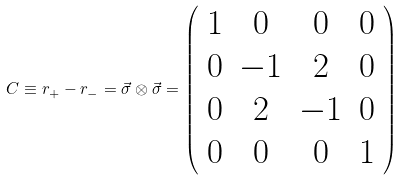Convert formula to latex. <formula><loc_0><loc_0><loc_500><loc_500>C \equiv r _ { + } - r _ { - } = \vec { \sigma } \otimes \vec { \sigma } = \left ( \begin{array} { c c c c } 1 & 0 & 0 & 0 \\ 0 & - 1 & 2 & 0 \\ 0 & 2 & - 1 & 0 \\ 0 & 0 & 0 & 1 \end{array} \right )</formula> 